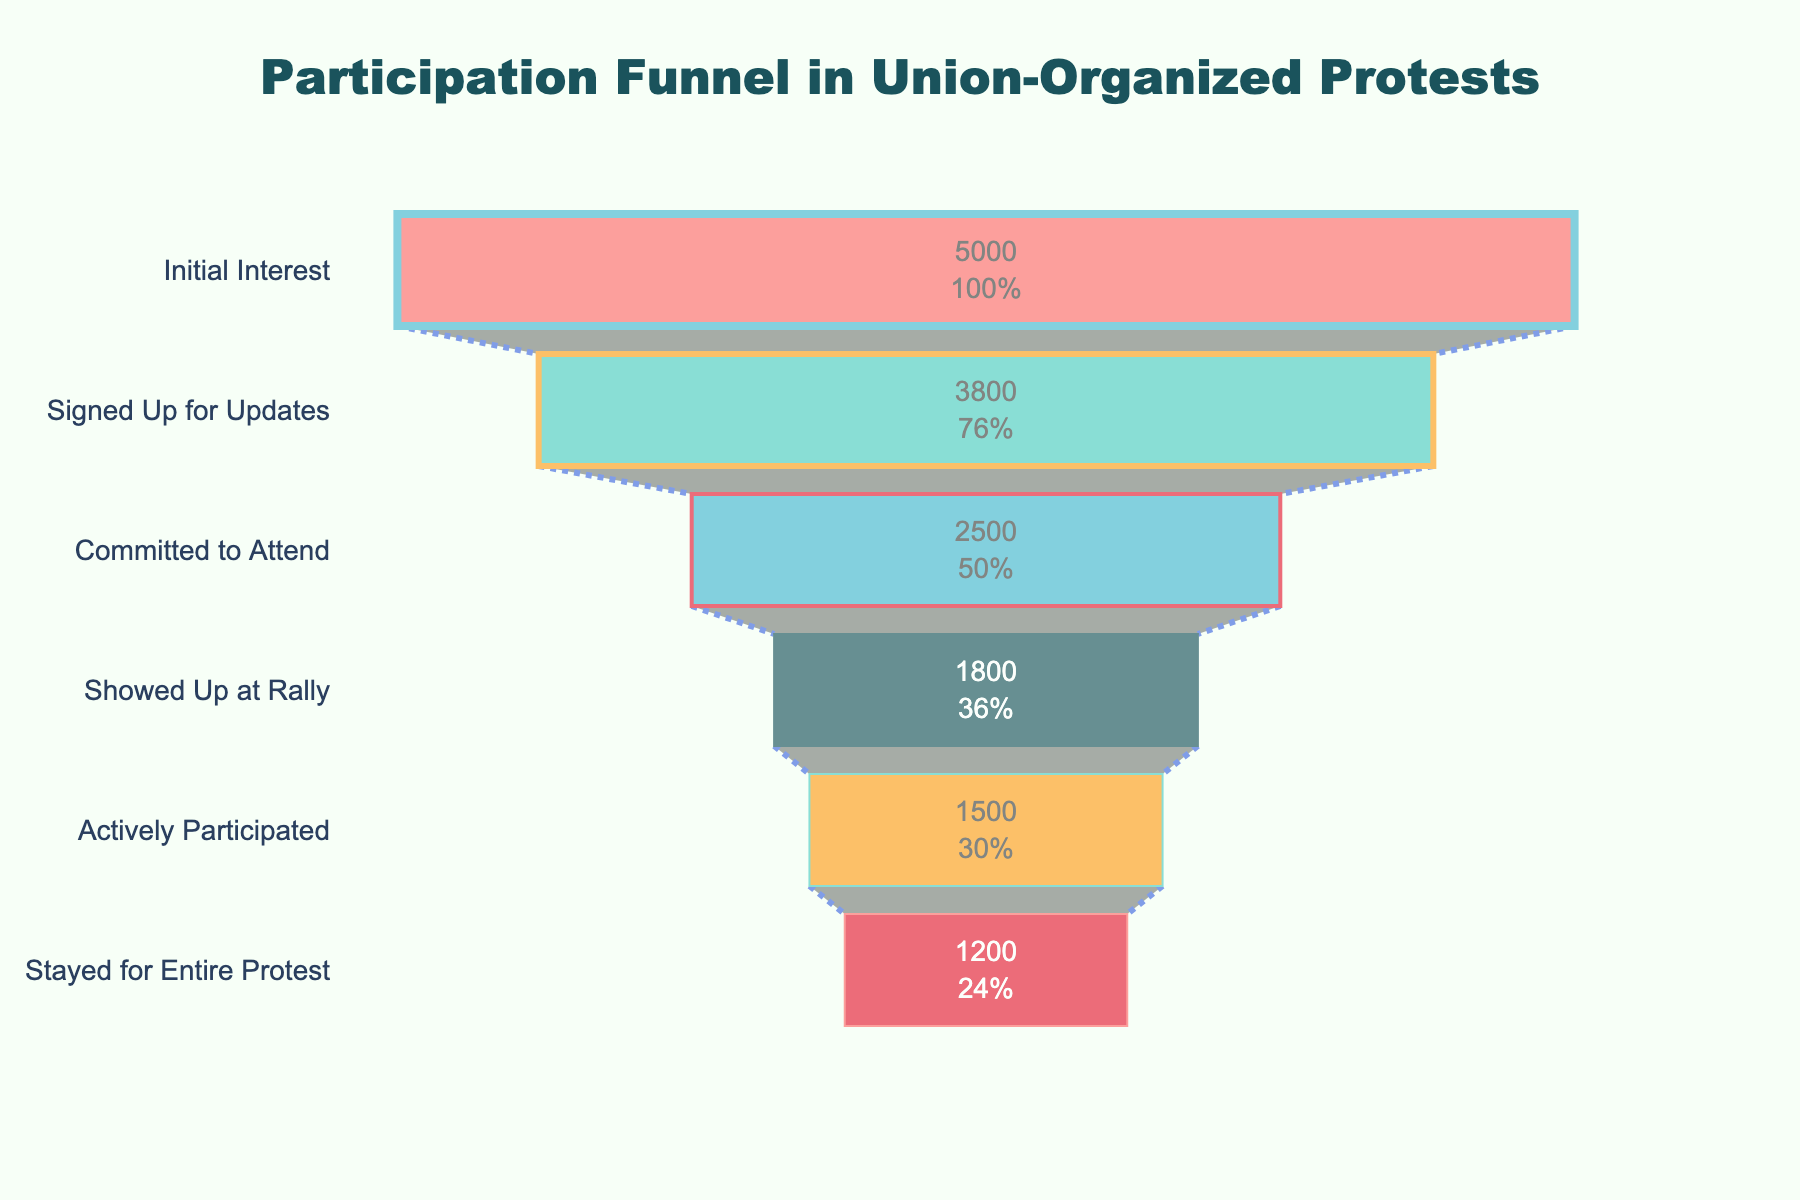What is the title of the figure? The title of the figure is located at the top and provides a summary of what the chart is about.
Answer: Participation Funnel in Union-Organized Protests How many stages are depicted in the funnel chart? By counting the different stages listed along the vertical axis.
Answer: Six What percentage of people who showed initial interest stayed for the entire protest? From the data, the number of people who stayed for the entire protest is 1200. The initial interest is 5000. Calculate the percentage with (1200/5000) * 100.
Answer: 24% What is the difference in the number of people between the 'Committed to Attend' stage and the 'Showed Up at Rally' stage? Subtract the number of people in the 'Showed Up at Rally' stage (1800) from the 'Committed to Attend' stage (2500).
Answer: 700 Which stage has the largest drop in participation? Compare the number of people between each consecutive stage and identify the stage with the highest drop. The largest drop is between 'Initial Interest' (5000) and 'Signed Up for Updates' (3800), which is 5000 - 3800.
Answer: Initial Interest to Signed Up for Updates What is the percentage loss of participants from the 'Committed to Attend' stage to the 'Showed Up at Rally' stage? Calculate the percentage loss with ((2500 - 1800) / 2500) * 100.
Answer: 28% Which stage has the lowest participation? Identify the stage with the smallest number of people, which is 'Stayed for Entire Protest' with 1200 people.
Answer: Stayed for Entire Protest Which color is used to represent the 'Signed Up for Updates' stage? The color associated with each stage is identified by the order provided, where 'Signed Up for Updates' is the second stage, and its color is light green.
Answer: Light green How many people dropped out between the 'Showed Up at Rally' stage and the 'Actively Participated' stage? Subtract the number of people in the 'Actively Participated' stage (1500) from the 'Showed Up at Rally' stage (1800).
Answer: 300 What is the retention rate from 'Signed Up for Updates' to 'Actively Participated'? The number of people in 'Signed Up for Updates' is 3800 and for 'Actively Participated' is 1500. Calculate the retention rate with (1500 / 3800) * 100.
Answer: 39.47% 